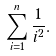<formula> <loc_0><loc_0><loc_500><loc_500>\sum _ { i = 1 } ^ { n } { \frac { 1 } { i ^ { 2 } } } .</formula> 